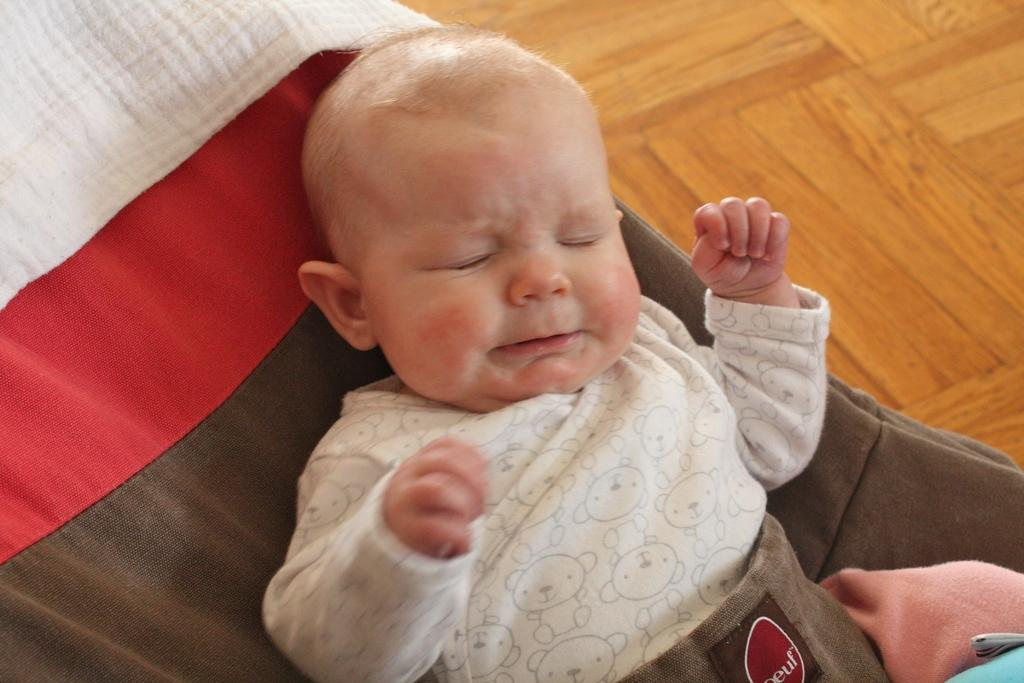What is the main subject of the picture? The main subject of the picture is a baby. What is the baby doing in the picture? The baby is lying down and crying. What type of surface is visible in the picture? There is a floor visible in the picture. What is the condition of the street outside the window in the image? There is no window or street visible in the image; it only features a baby lying down and crying on a floor. Can you see any ants crawling on the baby in the image? No, there are no ants present in the image. 